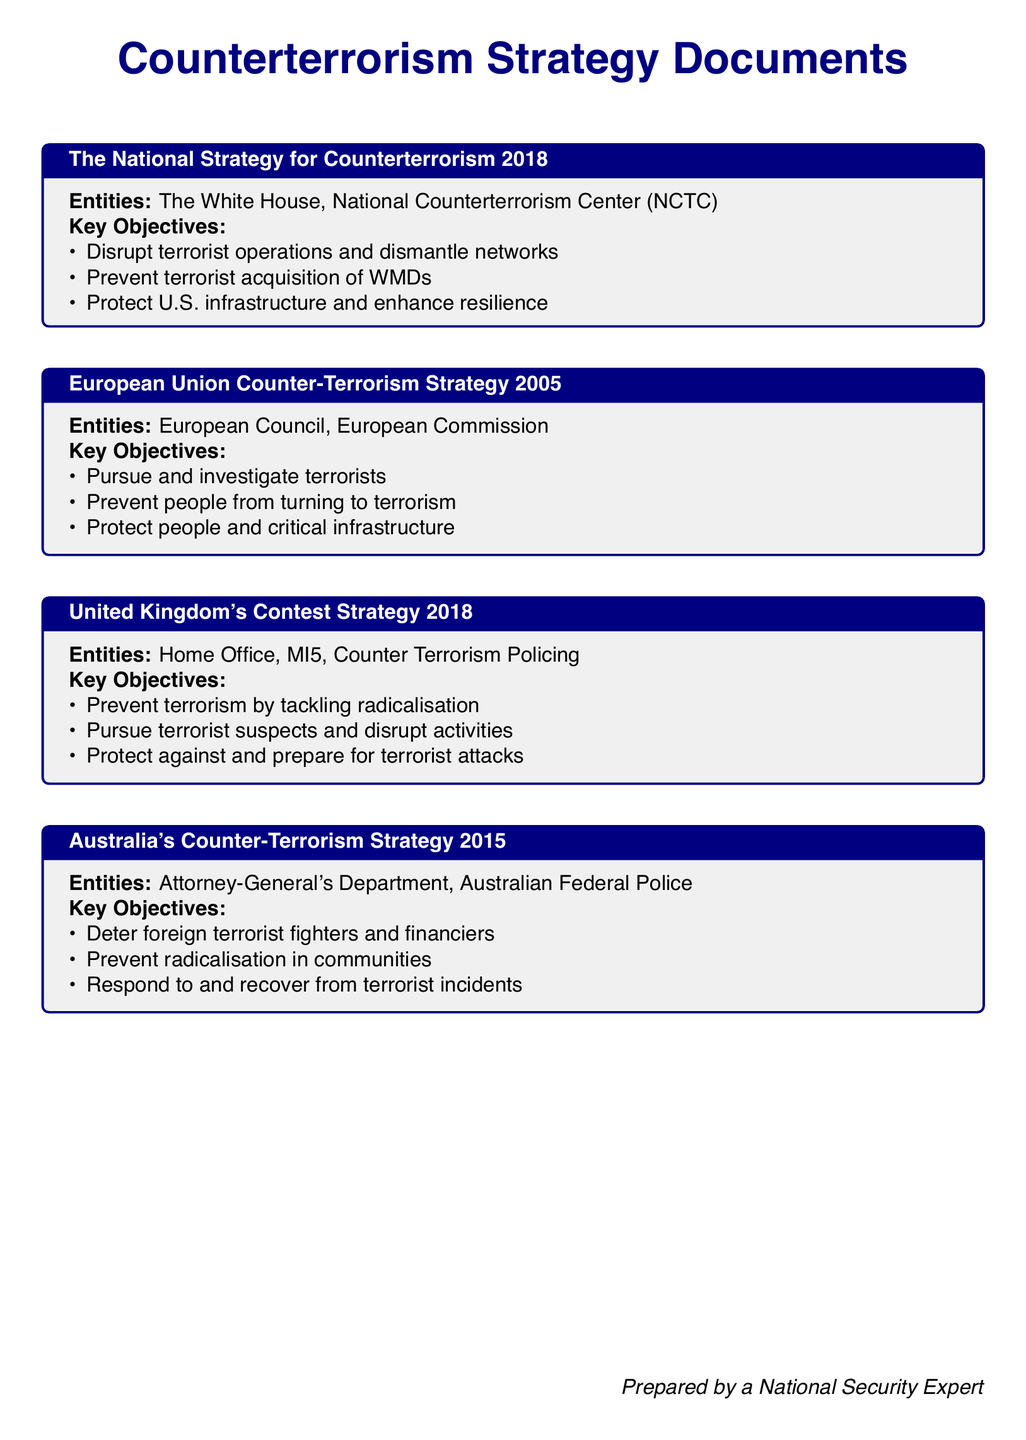What is the title of the 2018 U.S. strategy? The title is explicitly stated in the document.
Answer: The National Strategy for Counterterrorism 2018 Which entities are involved in Australia's Counter-Terrorism Strategy? The entities are listed in the box corresponding to Australia's strategy.
Answer: Attorney-General's Department, Australian Federal Police What is one key objective of the European Union Counter-Terrorism Strategy? The key objectives are outlined in a list format within the document.
Answer: Pursue and investigate terrorists How many key objectives does the United Kingdom's Contest Strategy list? This information can be counted from the objectives presented in the document.
Answer: Three Which strategy aims to prevent radicalisation in communities? The document shows specific objectives linked to each strategy.
Answer: Australia's Counter-Terrorism Strategy 2015 What year was the European Union Counter-Terrorism Strategy published? The year is part of the title of the respective strategy.
Answer: 2005 What is one operational plan from the U.K.'s Contest Strategy? A specific objective acts as an operational plan that can be found in the document.
Answer: Tackle radicalisation Which document discusses protecting U.S. infrastructure? This information can be identified from the objectives in the document.
Answer: The National Strategy for Counterterrorism 2018 What was the main focus of Australia's Counter-Terrorism Strategy? The key objectives reflect the main focus and urgency outlined in the strategy.
Answer: Deter foreign terrorist fighters and financiers 